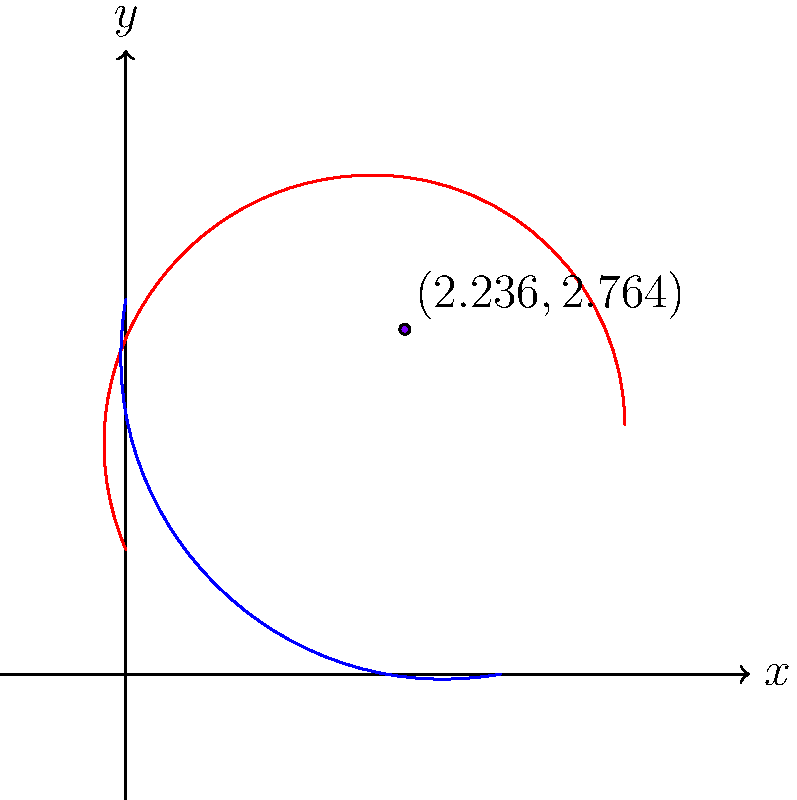In an epic battle scene, Iron Man's flight path can be modeled by the equation $y = -x^2 + 4x + 1$, while Captain America's shield throw trajectory follows the equation $y = -\frac{1}{3}x^2 + x + 3$. At what point do their paths intersect? Round your answer to three decimal places. To find the intersection point, we need to solve the system of equations:

1) Iron Man's flight path: $y = -x^2 + 4x + 1$
2) Captain America's shield trajectory: $y = -\frac{1}{3}x^2 + x + 3$

Step 1: Set the equations equal to each other
$-x^2 + 4x + 1 = -\frac{1}{3}x^2 + x + 3$

Step 2: Subtract the right side from both sides
$-x^2 + 4x + 1 - (-\frac{1}{3}x^2 + x + 3) = 0$

Step 3: Simplify
$-x^2 + 4x + 1 + \frac{1}{3}x^2 - x - 3 = 0$
$-\frac{3}{3}x^2 + \frac{1}{3}x^2 + 4x - x + 1 - 3 = 0$
$-\frac{2}{3}x^2 + 3x - 2 = 0$

Step 4: Multiply all terms by 3 to eliminate fractions
$-2x^2 + 9x - 6 = 0$

Step 5: Use the quadratic formula $x = \frac{-b \pm \sqrt{b^2 - 4ac}}{2a}$
$a = -2$, $b = 9$, $c = -6$

$x = \frac{-9 \pm \sqrt{81 - 4(-2)(-6)}}{2(-2)}$
$x = \frac{-9 \pm \sqrt{81 - 48}}{-4}$
$x = \frac{-9 \pm \sqrt{33}}{-4}$

Step 6: Solve for both solutions
$x_1 = \frac{-9 + \sqrt{33}}{-4} \approx 0.764$
$x_2 = \frac{-9 - \sqrt{33}}{-4} \approx 2.236$

Step 7: Choose the solution within the visible range (0 to 4)
$x = 2.236$

Step 8: Find the corresponding y-value using either equation
$y = -(-2.236)^2 + 4(2.236) + 1 \approx 2.764$

Therefore, the intersection point is approximately (2.236, 2.764).
Answer: (2.236, 2.764) 